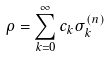<formula> <loc_0><loc_0><loc_500><loc_500>\rho = \sum _ { k = 0 } ^ { \infty } c _ { k } \sigma _ { k } ^ { ( n ) }</formula> 